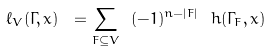<formula> <loc_0><loc_0><loc_500><loc_500>\ell _ { V } ( \Gamma , x ) \ = \sum _ { F \subseteq V } \ ( - 1 ) ^ { n - | F | } \ h ( \Gamma _ { F } , x )</formula> 